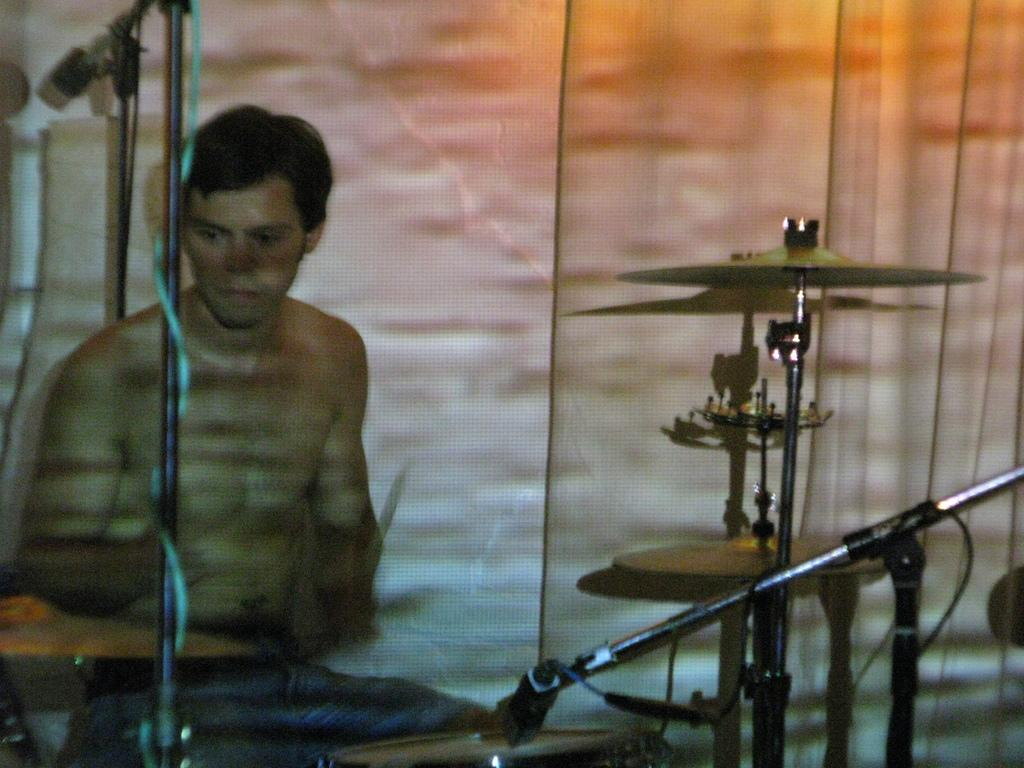Who is the main subject in the image? There is a man in the image. What is the man doing in the image? The man is playing drums. What objects are present in front of the man? There are microphones in front of the man. What invention can be seen in the man's hand while playing the drums? There is no invention visible in the man's hand while playing the drums in the image. 